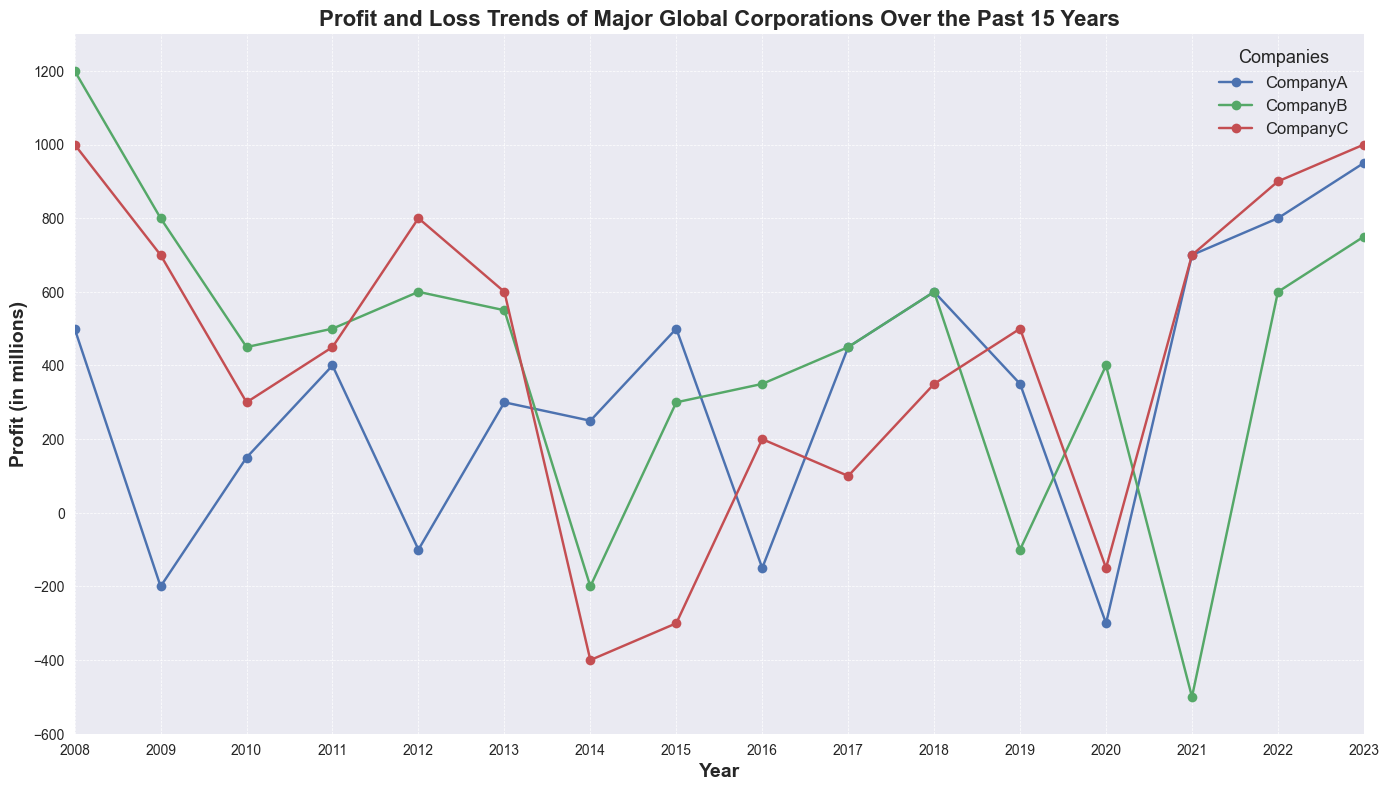What is the overall trend of Company A's profits over the past 15 years? Look at Company A's data points from 2008 to 2023. Notice the fluctuations including years with losses (negative values) and overall observe the upward and downward trends. The final point in 2023 can give an indication about the long-term direction. Despite fluctuations, there's generally an increasing trend towards the positive end in 2023.
Answer: Increasing Which year did Company C have the lowest profit value? To find the lowest profit, examine Company C's line and identify the lowest point. The data shows that the lowest point appears in 2014 at -400.
Answer: 2014 Between Company B and Company C, which company had a higher profit in 2010? Compare the profit values for both companies in 2010. Company B had 450, while Company C had 300. Therefore, Company B's profit was higher.
Answer: Company B During which year did Company A experience the most significant loss? To find the most significant loss, locate the most negative value in Company A's profit data. In 2020, Company A had a profit of -300.
Answer: 2020 Calculate the average profit of Company B over the past 15 years. Sum up all the annual profits from 2008 to 2023 for Company B and then divide by the number of values (16 years). The total profit = 1200 + 800 + 450 + 500 + 600 + 550 + (-200) + 300 + 350 + 450 + 600 + (-100) + 400 + (-500) + 600 + 750 = 7750. The average profit = 7750 / 16 = 484.375.
Answer: 484.375 How many times did Company A experiences negative profits? Count the number of years where Company A's profit is less than 0. From the data, the years are 2009 (-200), 2012 (-100), 2016 (-150), and 2020 (-300) altogether make 4 years.
Answer: 4 In which year did all three companies have positive profits? Locate a year where none of the companies have negative profit values. Upon inspecting the data points, each company shows positive profit in 2018.
Answer: 2018 Compare the profit trends between Company A and Company C over the 15-year period. Which company has more consistent profits? Look at fluctuations in the lines for each company. Company A shows significant negative and positive swings. Company C had more negative years, but its trend is more consistently positive from 2017 onwards. Therefore, Company C had relatively more consistent overall.
Answer: Company C In which years did Company B experience losses? How many such years are there? Identify years where Company B's profit is less than 0. The years are 2014 (-200), 2019 (-100), and 2021 (-500). So, there are 3 years of losses.
Answer: 3 years What was the maximum profit Company C achieved, and in which year? Find the peak value of Company C and the corresponding year from the graph. The maximum profit of Company C was 1000, achieved in 2008 and 2023.
Answer: 1000, in 2008 and 2023 